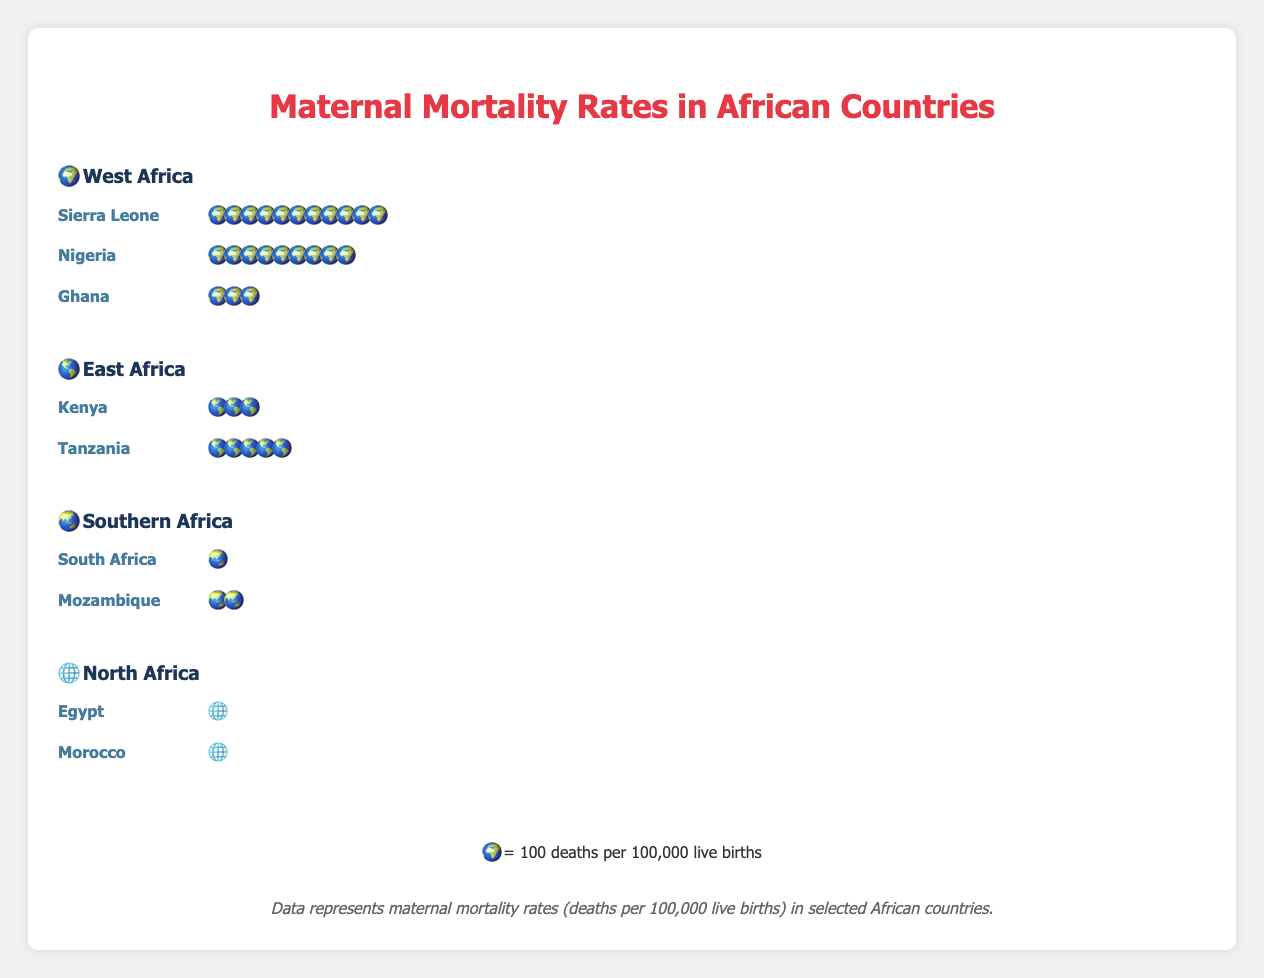What is the maternal mortality rate for Sierra Leone? The figure shows that Sierra Leone's rate is represented by the number of icons (each icon represents 100 deaths per 100,000 live births). There are 11 icons.
Answer: 1100 deaths per 100,000 live births Which country in West Africa has the highest maternal mortality rate? In the West Africa region, we compare the number of icons for each country. Sierra Leone has the most icons (11) compared to Nigeria (9) and Ghana (3).
Answer: Sierra Leone How many countries in the figure have a maternal mortality rate below 100 deaths per 100,000 live births? Count the countries and their respective icon representations. Only Egypt and Morocco each have one icon, which is below 100.
Answer: 2 countries Which region in the figure has the lowest average maternal mortality rate? Calculate the average rate for each region: West Africa (1120+917+308)/3, East Africa (342+524)/2, Southern Africa (119+289)/2, and North Africa (37+70)/2. Compare the results to find the lowest. Detailed calculation needed.
Answer: North Africa What is the total maternal mortality rate for all countries represented in the Southern Africa region? Add the rates for South Africa (1 icon) and Mozambique (2 icons), each representing 100 deaths. So, 100 * 1 + 100 * 2 = 300 deaths per 100,000 live births.
Answer: 300 deaths per 100,000 live births Which country has the lowest maternal mortality rate? In the figure, the country with the fewest number of icons represents the lowest maternal mortality rate. Egypt has the fewest icons (1).
Answer: Egypt How many more deaths per 100,000 live births does Tanzania have compared to Ghana? Tanzania has 5 icons (500 deaths) and Ghana has 3 icons (300 deaths). The difference is 500 - 300 = 200.
Answer: 200 Which region has the widest range of maternal mortality rates among its countries? The range is the difference between the highest and lowest rates within a region. Calculate the difference for each region and compare. West Africa: 1120 - 308, East Africa: 524 - 342, Southern Africa: 289 - 119, North Africa: 70 - 37. Detailed calculation shows West Africa has the widest range (1120 - 308 = 812).
Answer: West Africa 